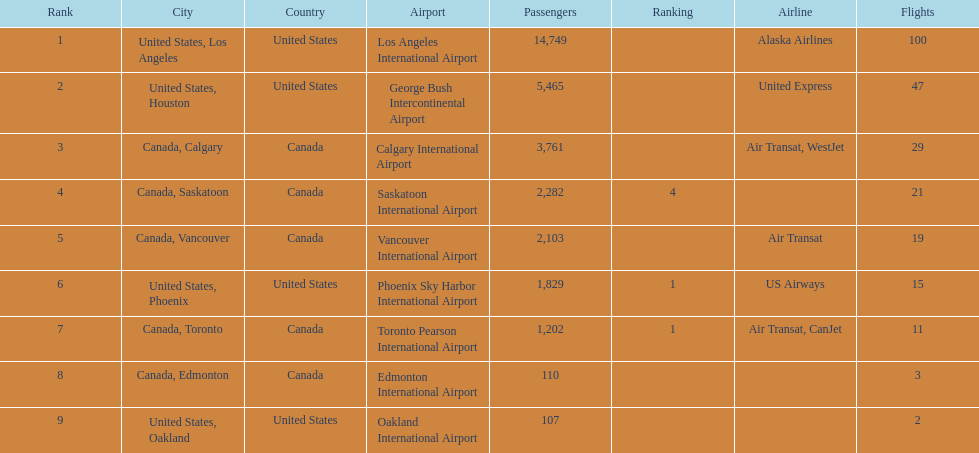How many cities from canada are on this list? 5. 